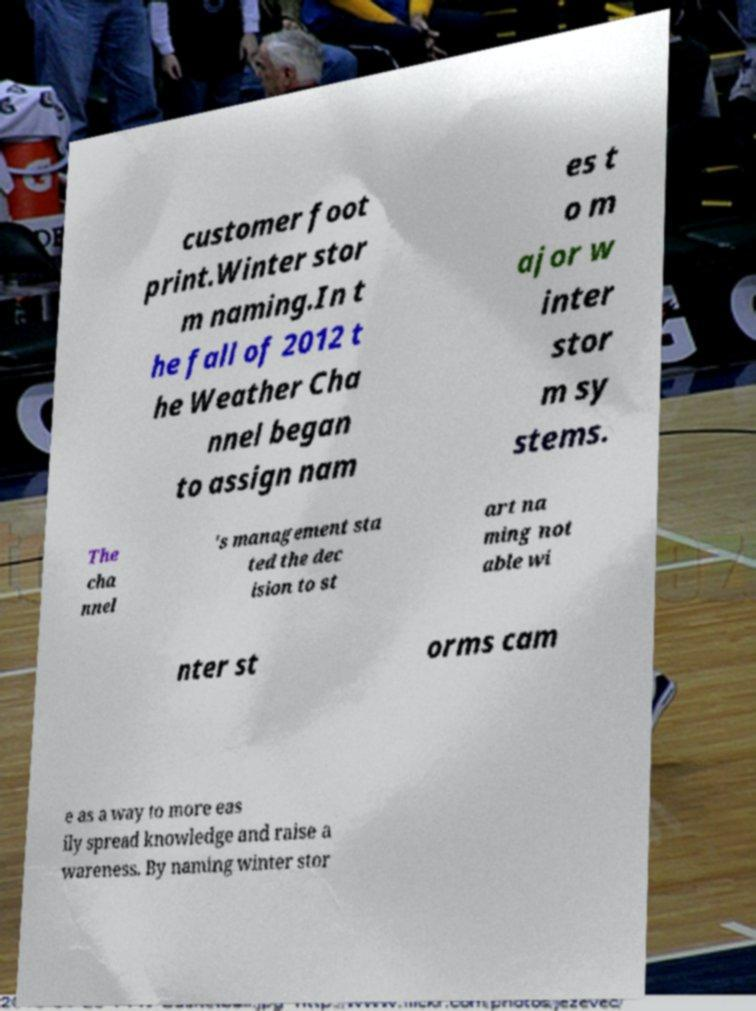Please read and relay the text visible in this image. What does it say? customer foot print.Winter stor m naming.In t he fall of 2012 t he Weather Cha nnel began to assign nam es t o m ajor w inter stor m sy stems. The cha nnel 's management sta ted the dec ision to st art na ming not able wi nter st orms cam e as a way to more eas ily spread knowledge and raise a wareness. By naming winter stor 